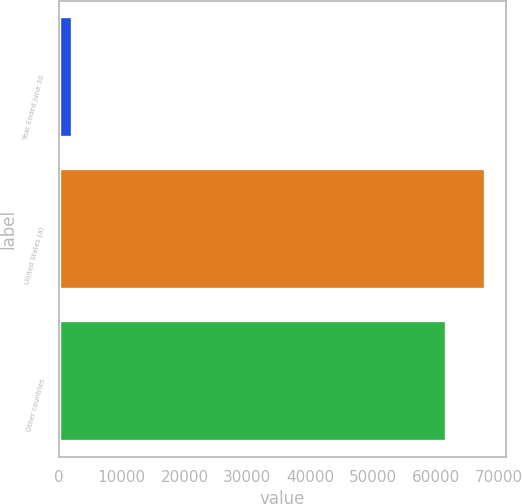<chart> <loc_0><loc_0><loc_500><loc_500><bar_chart><fcel>Year Ended June 30<fcel>United States (a)<fcel>Other countries<nl><fcel>2019<fcel>67862<fcel>61644<nl></chart> 